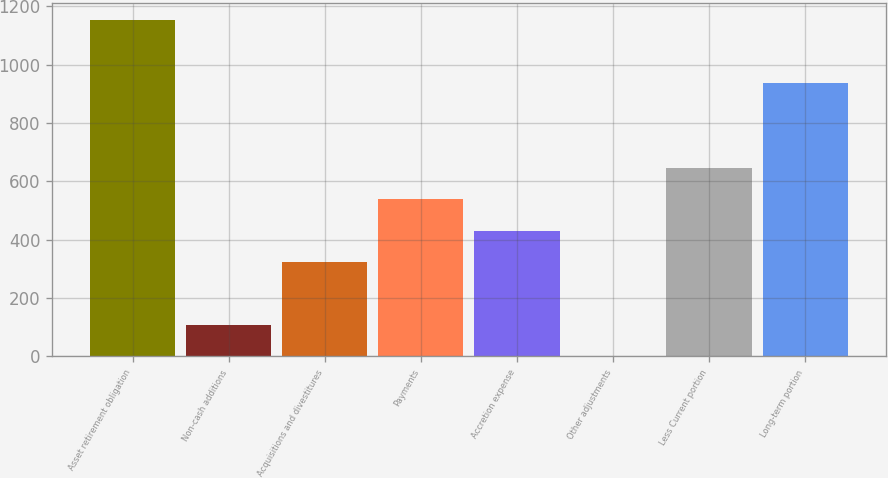Convert chart to OTSL. <chart><loc_0><loc_0><loc_500><loc_500><bar_chart><fcel>Asset retirement obligation<fcel>Non-cash additions<fcel>Acquisitions and divestitures<fcel>Payments<fcel>Accretion expense<fcel>Other adjustments<fcel>Less Current portion<fcel>Long-term portion<nl><fcel>1151.62<fcel>108.71<fcel>323.33<fcel>537.95<fcel>430.64<fcel>1.4<fcel>645.26<fcel>937<nl></chart> 